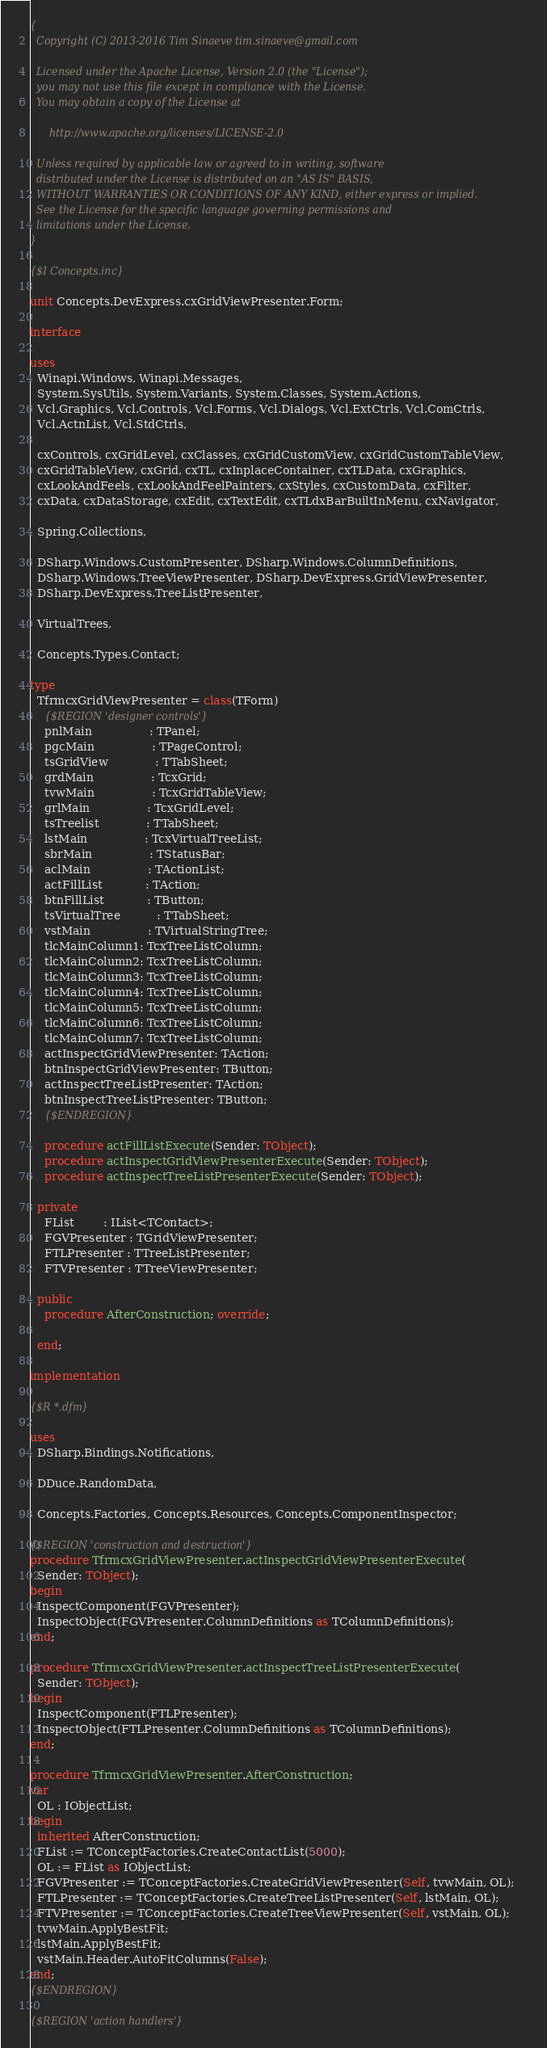<code> <loc_0><loc_0><loc_500><loc_500><_Pascal_>{
  Copyright (C) 2013-2016 Tim Sinaeve tim.sinaeve@gmail.com

  Licensed under the Apache License, Version 2.0 (the "License");
  you may not use this file except in compliance with the License.
  You may obtain a copy of the License at

      http://www.apache.org/licenses/LICENSE-2.0

  Unless required by applicable law or agreed to in writing, software
  distributed under the License is distributed on an "AS IS" BASIS,
  WITHOUT WARRANTIES OR CONDITIONS OF ANY KIND, either express or implied.
  See the License for the specific language governing permissions and
  limitations under the License.
}

{$I Concepts.inc}

unit Concepts.DevExpress.cxGridViewPresenter.Form;

interface

uses
  Winapi.Windows, Winapi.Messages,
  System.SysUtils, System.Variants, System.Classes, System.Actions,
  Vcl.Graphics, Vcl.Controls, Vcl.Forms, Vcl.Dialogs, Vcl.ExtCtrls, Vcl.ComCtrls,
  Vcl.ActnList, Vcl.StdCtrls,

  cxControls, cxGridLevel, cxClasses, cxGridCustomView, cxGridCustomTableView,
  cxGridTableView, cxGrid, cxTL, cxInplaceContainer, cxTLData, cxGraphics,
  cxLookAndFeels, cxLookAndFeelPainters, cxStyles, cxCustomData, cxFilter,
  cxData, cxDataStorage, cxEdit, cxTextEdit, cxTLdxBarBuiltInMenu, cxNavigator,

  Spring.Collections,

  DSharp.Windows.CustomPresenter, DSharp.Windows.ColumnDefinitions,
  DSharp.Windows.TreeViewPresenter, DSharp.DevExpress.GridViewPresenter,
  DSharp.DevExpress.TreeListPresenter,

  VirtualTrees,

  Concepts.Types.Contact;

type
  TfrmcxGridViewPresenter = class(TForm)
    {$REGION 'designer controls'}
    pnlMain                : TPanel;
    pgcMain                : TPageControl;
    tsGridView             : TTabSheet;
    grdMain                : TcxGrid;
    tvwMain                : TcxGridTableView;
    grlMain                : TcxGridLevel;
    tsTreelist             : TTabSheet;
    lstMain                : TcxVirtualTreeList;
    sbrMain                : TStatusBar;
    aclMain                : TActionList;
    actFillList            : TAction;
    btnFillList            : TButton;
    tsVirtualTree          : TTabSheet;
    vstMain                : TVirtualStringTree;
    tlcMainColumn1: TcxTreeListColumn;
    tlcMainColumn2: TcxTreeListColumn;
    tlcMainColumn3: TcxTreeListColumn;
    tlcMainColumn4: TcxTreeListColumn;
    tlcMainColumn5: TcxTreeListColumn;
    tlcMainColumn6: TcxTreeListColumn;
    tlcMainColumn7: TcxTreeListColumn;
    actInspectGridViewPresenter: TAction;
    btnInspectGridViewPresenter: TButton;
    actInspectTreeListPresenter: TAction;
    btnInspectTreeListPresenter: TButton;
    {$ENDREGION}

    procedure actFillListExecute(Sender: TObject);
    procedure actInspectGridViewPresenterExecute(Sender: TObject);
    procedure actInspectTreeListPresenterExecute(Sender: TObject);

  private
    FList        : IList<TContact>;
    FGVPresenter : TGridViewPresenter;
    FTLPresenter : TTreeListPresenter;
    FTVPresenter : TTreeViewPresenter;

  public
    procedure AfterConstruction; override;

  end;

implementation

{$R *.dfm}

uses
  DSharp.Bindings.Notifications,

  DDuce.RandomData,

  Concepts.Factories, Concepts.Resources, Concepts.ComponentInspector;

{$REGION 'construction and destruction'}
procedure TfrmcxGridViewPresenter.actInspectGridViewPresenterExecute(
  Sender: TObject);
begin
  InspectComponent(FGVPresenter);
  InspectObject(FGVPresenter.ColumnDefinitions as TColumnDefinitions);
end;

procedure TfrmcxGridViewPresenter.actInspectTreeListPresenterExecute(
  Sender: TObject);
begin
  InspectComponent(FTLPresenter);
  InspectObject(FTLPresenter.ColumnDefinitions as TColumnDefinitions);
end;

procedure TfrmcxGridViewPresenter.AfterConstruction;
var
  OL : IObjectList;
begin
  inherited AfterConstruction;
  FList := TConceptFactories.CreateContactList(5000);
  OL := FList as IObjectList;
  FGVPresenter := TConceptFactories.CreateGridViewPresenter(Self, tvwMain, OL);
  FTLPresenter := TConceptFactories.CreateTreeListPresenter(Self, lstMain, OL);
  FTVPresenter := TConceptFactories.CreateTreeViewPresenter(Self, vstMain, OL);
  tvwMain.ApplyBestFit;
  lstMain.ApplyBestFit;
  vstMain.Header.AutoFitColumns(False);
end;
{$ENDREGION}

{$REGION 'action handlers'}</code> 